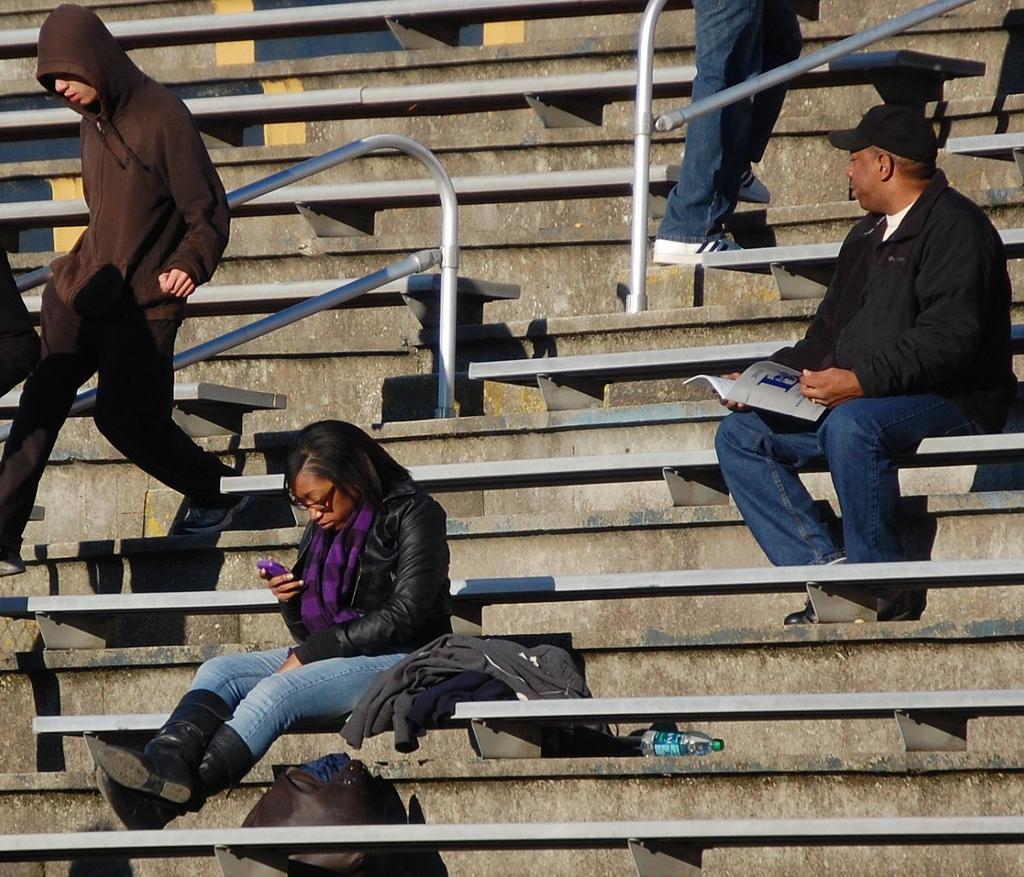How many people are seated?
Give a very brief answer. 2. How many women are there?
Give a very brief answer. 1. How many hats are there?
Give a very brief answer. 1. How many water bottles are there?
Give a very brief answer. 1. How many males do you see?
Give a very brief answer. 2. How many males are sitting down?
Give a very brief answer. 1. 